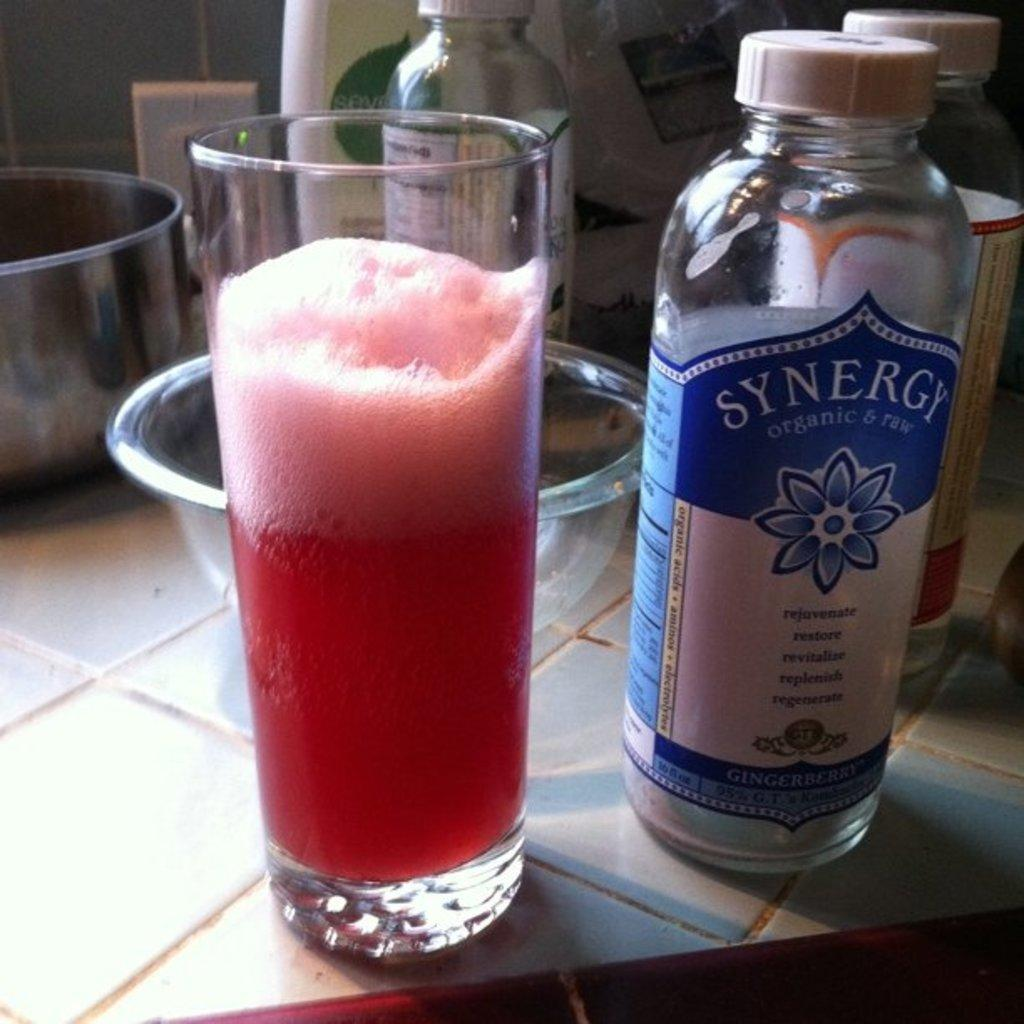What type of containers can be seen in the image? There are bottles and a bowl in the image. What else can be seen in the image besides the containers? There is a glass in the image. What is inside the glass? The glass contains a drink. How many legs does the mother have in the image? There is no mother present in the image, so it is not possible to determine the number of legs she might have. 